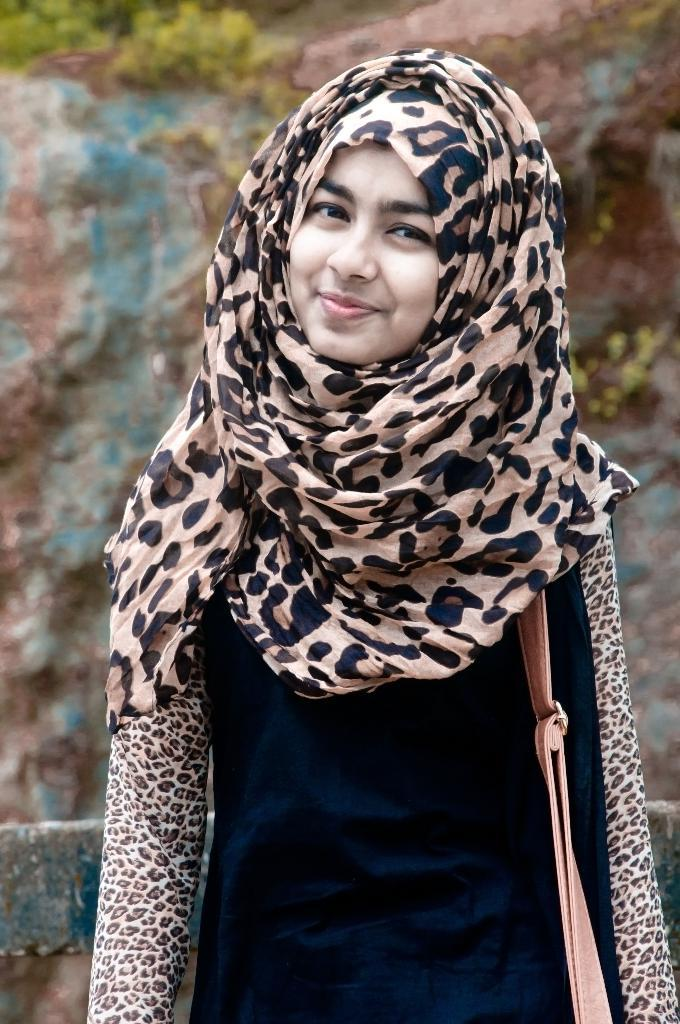What is the woman in the image doing? The woman is standing in the image and smiling. What can be seen in the woman's hand? There is a wire bag in the image. How would you describe the background of the image? The background of the image is blurry. What type of vegetation is visible in the background? There are plants visible in the background of the image. What type of marble is visible on the ground in the image? There is no marble visible on the ground in the image. Is the woman wearing a chain around her neck in the image? The image does not provide information about any jewelry the woman might be wearing. --- 